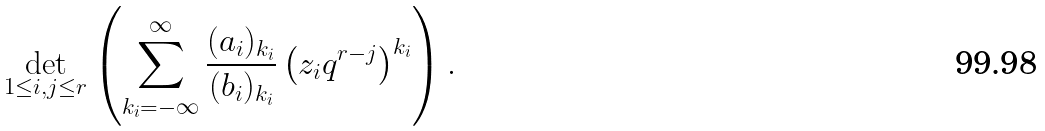<formula> <loc_0><loc_0><loc_500><loc_500>\det _ { 1 \leq i , j \leq r } \left ( \sum _ { k _ { i } = - \infty } ^ { \infty } \frac { ( a _ { i } ) _ { k _ { i } } } { ( b _ { i } ) _ { k _ { i } } } \left ( z _ { i } q ^ { r - j } \right ) ^ { k _ { i } } \right ) .</formula> 